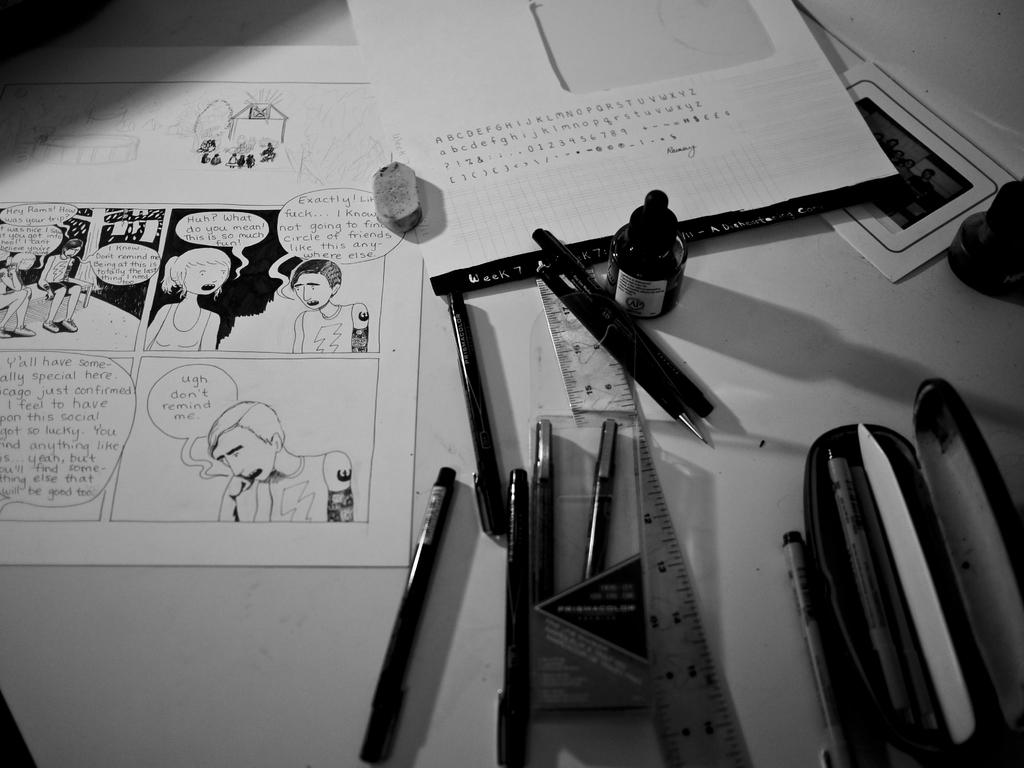What is the color scheme of the image? The image is black and white. What items can be seen on the table in the image? Papers, pens, a box, an ink bottle, a scale, and an eraser are visible on the table. Can you describe the type of objects on the table? The objects on the table include stationery items like pens and an ink bottle, as well as a scale and an eraser. What type of gun is present on the table in the image? There is no gun present on the table in the image. What type of shock can be seen on the faces of the people in the image? There are no people present in the image, so it is not possible to determine their facial expressions or any potential shock. 